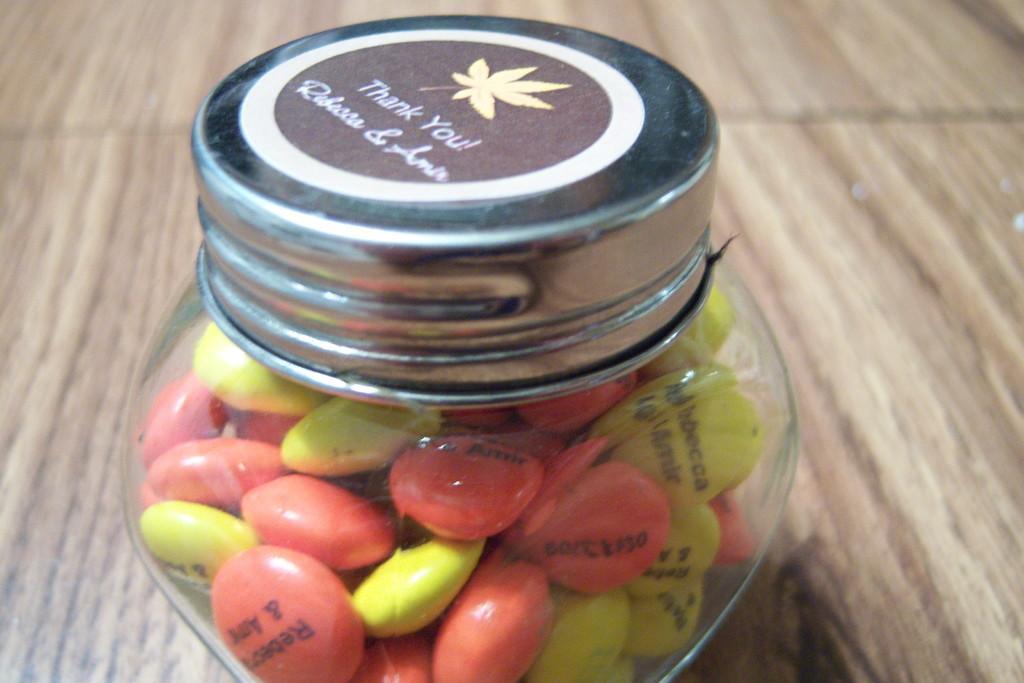Please provide a concise description of this image. This image is taken indoors. At the bottom of the image there is a table with a bottle of candies on it. 